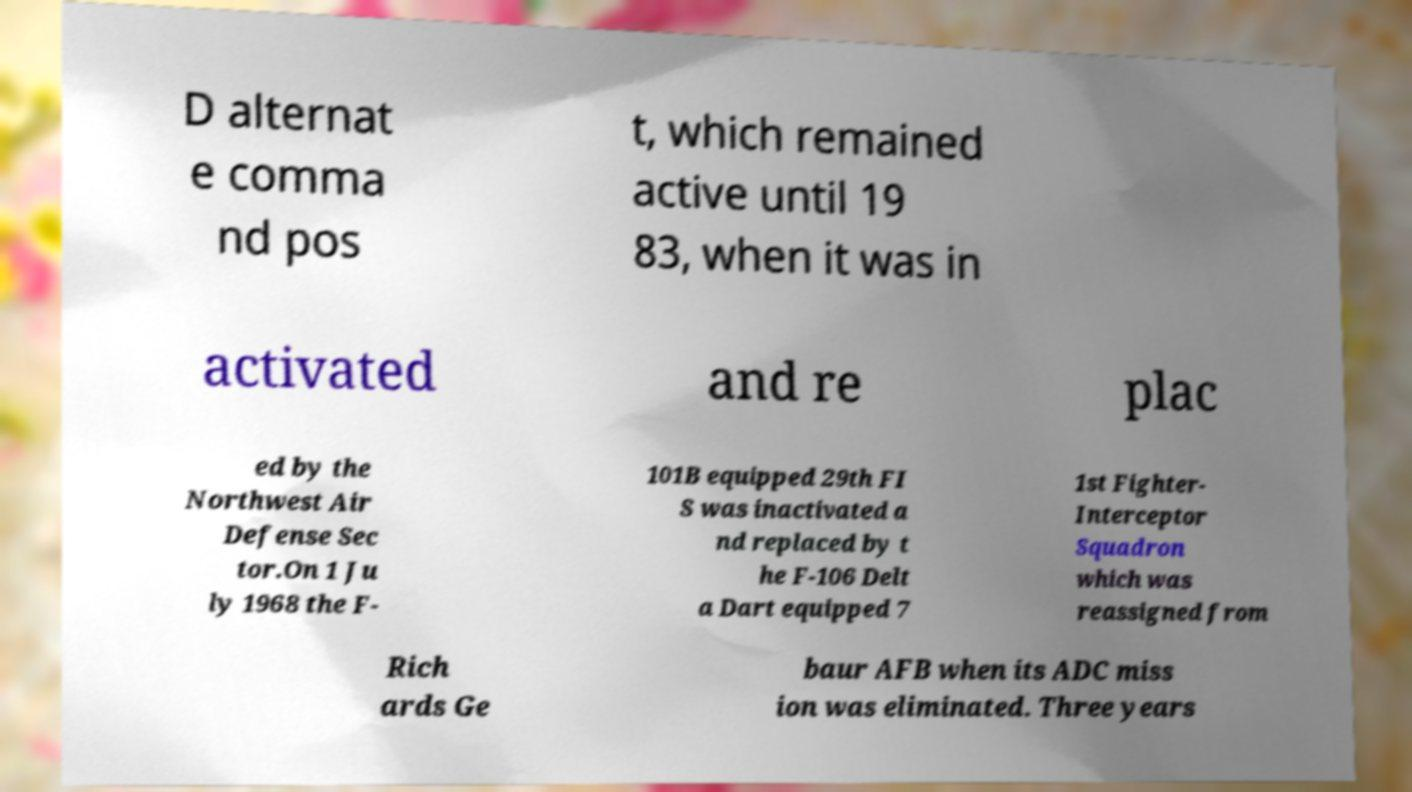For documentation purposes, I need the text within this image transcribed. Could you provide that? D alternat e comma nd pos t, which remained active until 19 83, when it was in activated and re plac ed by the Northwest Air Defense Sec tor.On 1 Ju ly 1968 the F- 101B equipped 29th FI S was inactivated a nd replaced by t he F-106 Delt a Dart equipped 7 1st Fighter- Interceptor Squadron which was reassigned from Rich ards Ge baur AFB when its ADC miss ion was eliminated. Three years 